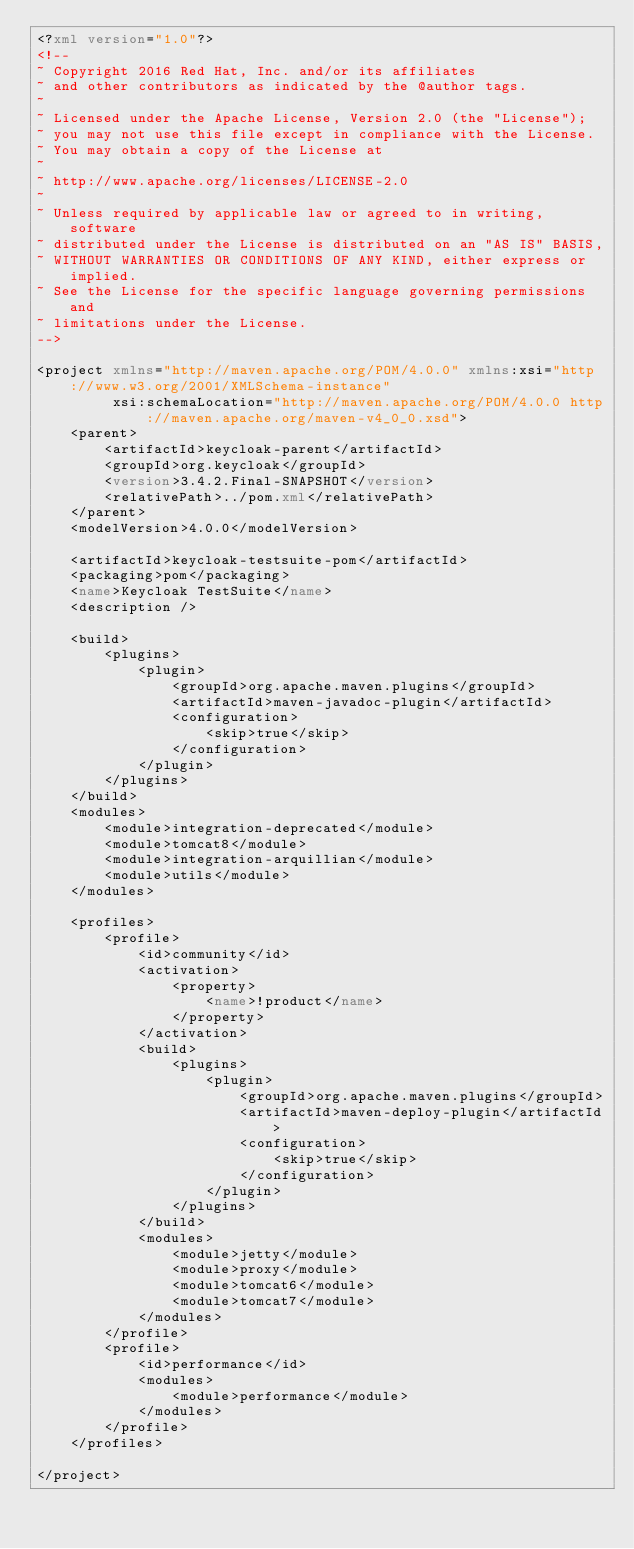Convert code to text. <code><loc_0><loc_0><loc_500><loc_500><_XML_><?xml version="1.0"?>
<!--
~ Copyright 2016 Red Hat, Inc. and/or its affiliates
~ and other contributors as indicated by the @author tags.
~
~ Licensed under the Apache License, Version 2.0 (the "License");
~ you may not use this file except in compliance with the License.
~ You may obtain a copy of the License at
~
~ http://www.apache.org/licenses/LICENSE-2.0
~
~ Unless required by applicable law or agreed to in writing, software
~ distributed under the License is distributed on an "AS IS" BASIS,
~ WITHOUT WARRANTIES OR CONDITIONS OF ANY KIND, either express or implied.
~ See the License for the specific language governing permissions and
~ limitations under the License.
-->

<project xmlns="http://maven.apache.org/POM/4.0.0" xmlns:xsi="http://www.w3.org/2001/XMLSchema-instance"
         xsi:schemaLocation="http://maven.apache.org/POM/4.0.0 http://maven.apache.org/maven-v4_0_0.xsd">
    <parent>
        <artifactId>keycloak-parent</artifactId>
        <groupId>org.keycloak</groupId>
        <version>3.4.2.Final-SNAPSHOT</version>
        <relativePath>../pom.xml</relativePath>
    </parent>
    <modelVersion>4.0.0</modelVersion>

    <artifactId>keycloak-testsuite-pom</artifactId>
    <packaging>pom</packaging>
    <name>Keycloak TestSuite</name>
    <description />

    <build>
        <plugins>
            <plugin>
                <groupId>org.apache.maven.plugins</groupId>
                <artifactId>maven-javadoc-plugin</artifactId>
                <configuration>
                    <skip>true</skip>
                </configuration>
            </plugin>
        </plugins>
    </build>
    <modules>
        <module>integration-deprecated</module>
        <module>tomcat8</module>
        <module>integration-arquillian</module>
        <module>utils</module>
    </modules>

    <profiles>
        <profile>
            <id>community</id>
            <activation>
                <property>
                    <name>!product</name>
                </property>
            </activation>
            <build>
                <plugins>
                    <plugin>
                        <groupId>org.apache.maven.plugins</groupId>
                        <artifactId>maven-deploy-plugin</artifactId>
                        <configuration>
                            <skip>true</skip>
                        </configuration>
                    </plugin>
                </plugins>
            </build>
            <modules>
                <module>jetty</module>
                <module>proxy</module>
                <module>tomcat6</module>
                <module>tomcat7</module>
            </modules>
        </profile>
        <profile>
            <id>performance</id>
            <modules>
                <module>performance</module>
            </modules>
        </profile>
    </profiles>
        
</project>
</code> 